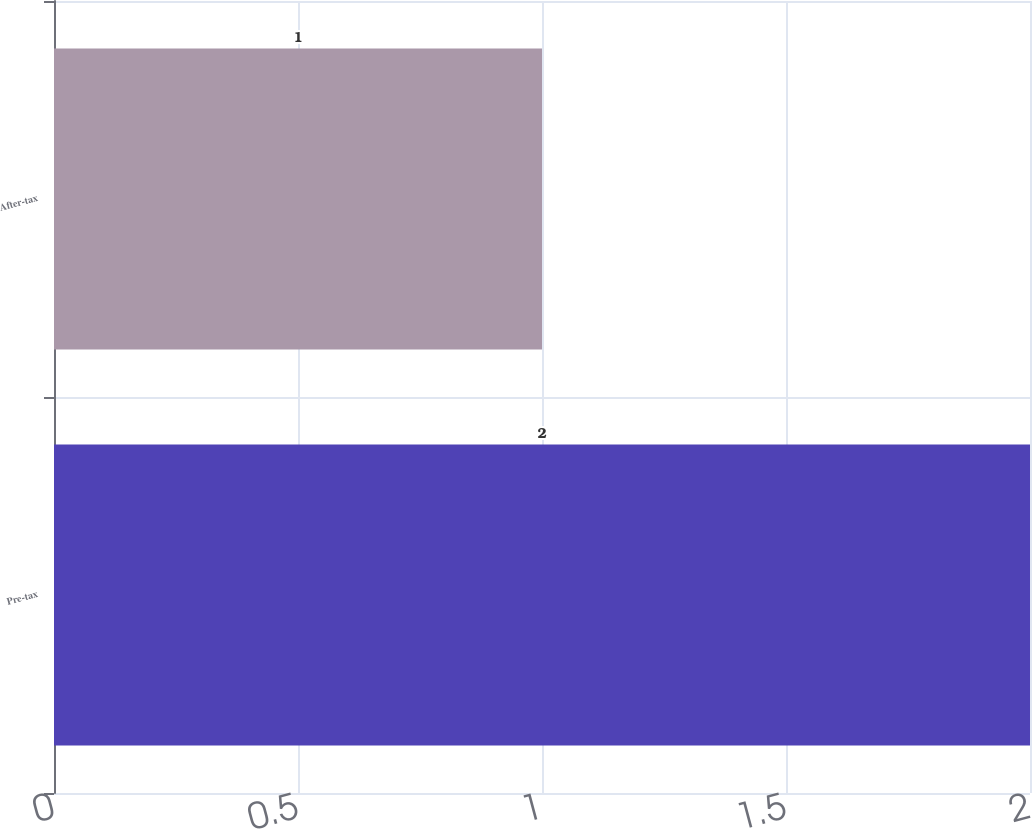Convert chart to OTSL. <chart><loc_0><loc_0><loc_500><loc_500><bar_chart><fcel>Pre-tax<fcel>After-tax<nl><fcel>2<fcel>1<nl></chart> 